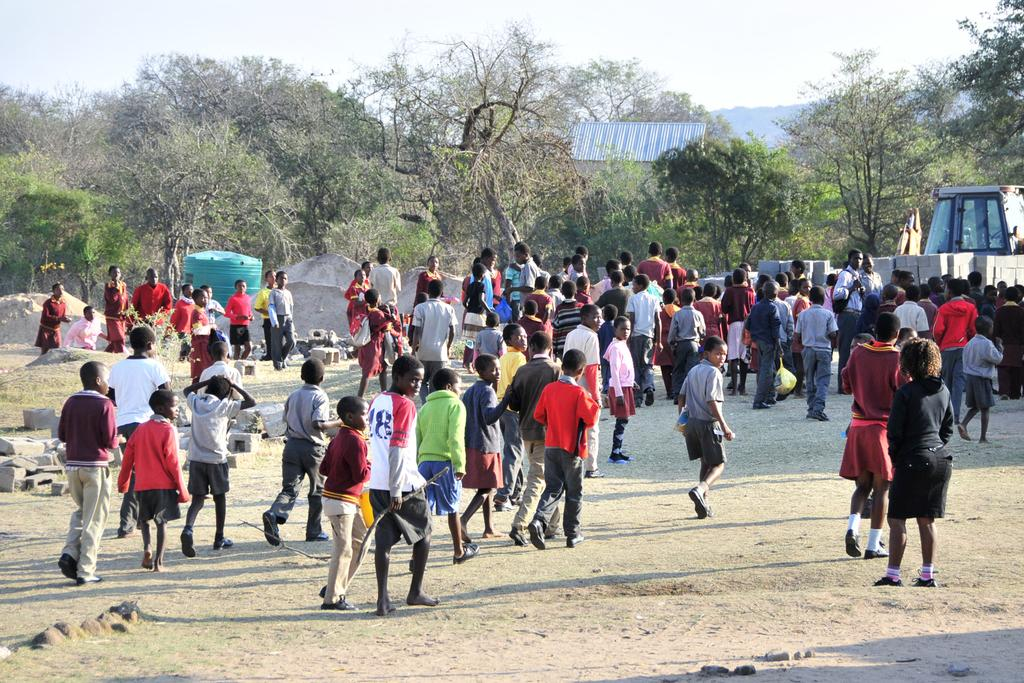How many individuals are present in the image? There are many people in the image. What is the position of the people in the image? The people are on the ground. What can be seen providing shade in the image? There is a shade in the image. What type of natural elements can be seen in the image? There are trees visible in the image. What type of stone is being used as a weapon by the creature in the image? There is no creature or stone present in the image. 